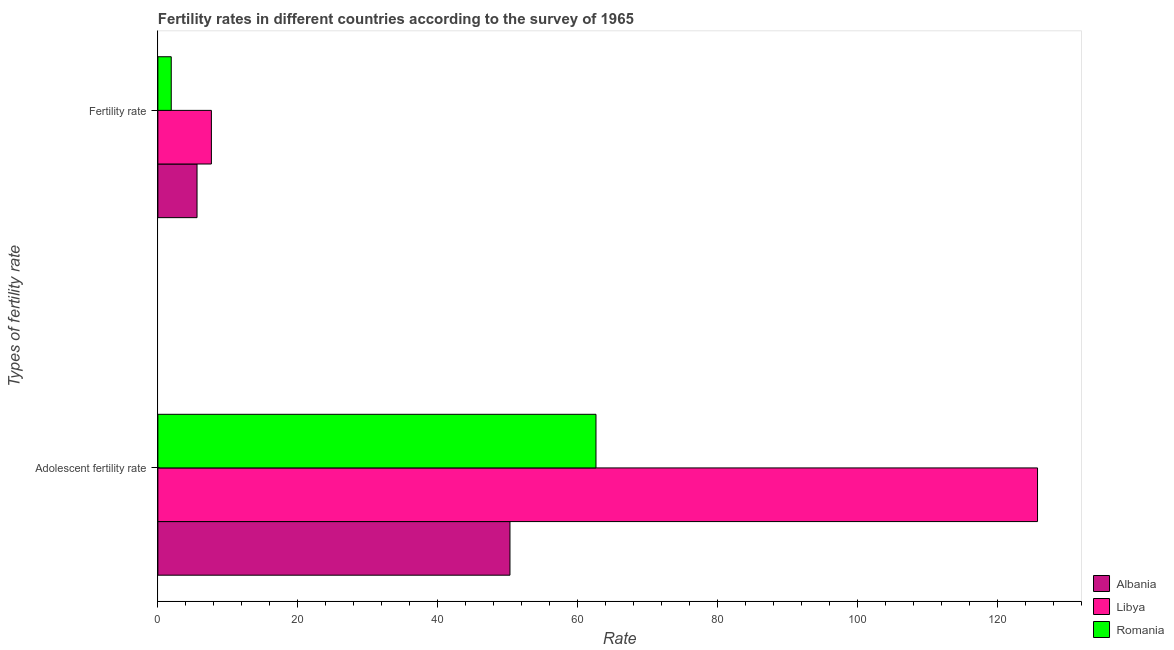How many different coloured bars are there?
Provide a succinct answer. 3. How many groups of bars are there?
Offer a terse response. 2. Are the number of bars per tick equal to the number of legend labels?
Provide a short and direct response. Yes. Are the number of bars on each tick of the Y-axis equal?
Provide a short and direct response. Yes. What is the label of the 2nd group of bars from the top?
Offer a very short reply. Adolescent fertility rate. What is the adolescent fertility rate in Libya?
Give a very brief answer. 125.73. Across all countries, what is the maximum adolescent fertility rate?
Ensure brevity in your answer.  125.73. Across all countries, what is the minimum fertility rate?
Provide a short and direct response. 1.91. In which country was the adolescent fertility rate maximum?
Make the answer very short. Libya. In which country was the fertility rate minimum?
Offer a very short reply. Romania. What is the total fertility rate in the graph?
Provide a succinct answer. 15.15. What is the difference between the fertility rate in Albania and that in Romania?
Give a very brief answer. 3.68. What is the difference between the fertility rate in Albania and the adolescent fertility rate in Romania?
Ensure brevity in your answer.  -57.02. What is the average fertility rate per country?
Ensure brevity in your answer.  5.05. What is the difference between the adolescent fertility rate and fertility rate in Libya?
Give a very brief answer. 118.08. What is the ratio of the fertility rate in Albania to that in Libya?
Ensure brevity in your answer.  0.73. Is the adolescent fertility rate in Libya less than that in Romania?
Make the answer very short. No. In how many countries, is the adolescent fertility rate greater than the average adolescent fertility rate taken over all countries?
Make the answer very short. 1. What does the 1st bar from the top in Adolescent fertility rate represents?
Offer a terse response. Romania. What does the 1st bar from the bottom in Fertility rate represents?
Offer a terse response. Albania. How many bars are there?
Give a very brief answer. 6. Are all the bars in the graph horizontal?
Give a very brief answer. Yes. Does the graph contain grids?
Give a very brief answer. No. Where does the legend appear in the graph?
Provide a short and direct response. Bottom right. How many legend labels are there?
Your answer should be compact. 3. How are the legend labels stacked?
Provide a short and direct response. Vertical. What is the title of the graph?
Ensure brevity in your answer.  Fertility rates in different countries according to the survey of 1965. Does "Gambia, The" appear as one of the legend labels in the graph?
Offer a terse response. No. What is the label or title of the X-axis?
Provide a succinct answer. Rate. What is the label or title of the Y-axis?
Keep it short and to the point. Types of fertility rate. What is the Rate in Albania in Adolescent fertility rate?
Keep it short and to the point. 50.32. What is the Rate of Libya in Adolescent fertility rate?
Offer a very short reply. 125.73. What is the Rate of Romania in Adolescent fertility rate?
Make the answer very short. 62.62. What is the Rate in Albania in Fertility rate?
Provide a short and direct response. 5.59. What is the Rate of Libya in Fertility rate?
Ensure brevity in your answer.  7.65. What is the Rate of Romania in Fertility rate?
Offer a very short reply. 1.91. Across all Types of fertility rate, what is the maximum Rate in Albania?
Offer a terse response. 50.32. Across all Types of fertility rate, what is the maximum Rate of Libya?
Provide a succinct answer. 125.73. Across all Types of fertility rate, what is the maximum Rate of Romania?
Offer a very short reply. 62.62. Across all Types of fertility rate, what is the minimum Rate of Albania?
Your response must be concise. 5.59. Across all Types of fertility rate, what is the minimum Rate of Libya?
Keep it short and to the point. 7.65. Across all Types of fertility rate, what is the minimum Rate of Romania?
Your response must be concise. 1.91. What is the total Rate of Albania in the graph?
Ensure brevity in your answer.  55.92. What is the total Rate of Libya in the graph?
Your response must be concise. 133.38. What is the total Rate of Romania in the graph?
Provide a short and direct response. 64.53. What is the difference between the Rate in Albania in Adolescent fertility rate and that in Fertility rate?
Offer a terse response. 44.73. What is the difference between the Rate in Libya in Adolescent fertility rate and that in Fertility rate?
Provide a short and direct response. 118.08. What is the difference between the Rate of Romania in Adolescent fertility rate and that in Fertility rate?
Your response must be concise. 60.71. What is the difference between the Rate of Albania in Adolescent fertility rate and the Rate of Libya in Fertility rate?
Ensure brevity in your answer.  42.68. What is the difference between the Rate of Albania in Adolescent fertility rate and the Rate of Romania in Fertility rate?
Keep it short and to the point. 48.41. What is the difference between the Rate of Libya in Adolescent fertility rate and the Rate of Romania in Fertility rate?
Give a very brief answer. 123.82. What is the average Rate in Albania per Types of fertility rate?
Your response must be concise. 27.96. What is the average Rate in Libya per Types of fertility rate?
Keep it short and to the point. 66.69. What is the average Rate in Romania per Types of fertility rate?
Keep it short and to the point. 32.26. What is the difference between the Rate of Albania and Rate of Libya in Adolescent fertility rate?
Provide a short and direct response. -75.4. What is the difference between the Rate in Albania and Rate in Romania in Adolescent fertility rate?
Your answer should be compact. -12.29. What is the difference between the Rate in Libya and Rate in Romania in Adolescent fertility rate?
Your answer should be very brief. 63.11. What is the difference between the Rate of Albania and Rate of Libya in Fertility rate?
Provide a succinct answer. -2.05. What is the difference between the Rate in Albania and Rate in Romania in Fertility rate?
Provide a short and direct response. 3.68. What is the difference between the Rate in Libya and Rate in Romania in Fertility rate?
Provide a succinct answer. 5.74. What is the ratio of the Rate of Albania in Adolescent fertility rate to that in Fertility rate?
Keep it short and to the point. 9. What is the ratio of the Rate in Libya in Adolescent fertility rate to that in Fertility rate?
Your answer should be very brief. 16.44. What is the ratio of the Rate in Romania in Adolescent fertility rate to that in Fertility rate?
Give a very brief answer. 32.78. What is the difference between the highest and the second highest Rate in Albania?
Ensure brevity in your answer.  44.73. What is the difference between the highest and the second highest Rate of Libya?
Ensure brevity in your answer.  118.08. What is the difference between the highest and the second highest Rate of Romania?
Provide a short and direct response. 60.71. What is the difference between the highest and the lowest Rate in Albania?
Offer a very short reply. 44.73. What is the difference between the highest and the lowest Rate of Libya?
Provide a short and direct response. 118.08. What is the difference between the highest and the lowest Rate in Romania?
Provide a succinct answer. 60.71. 